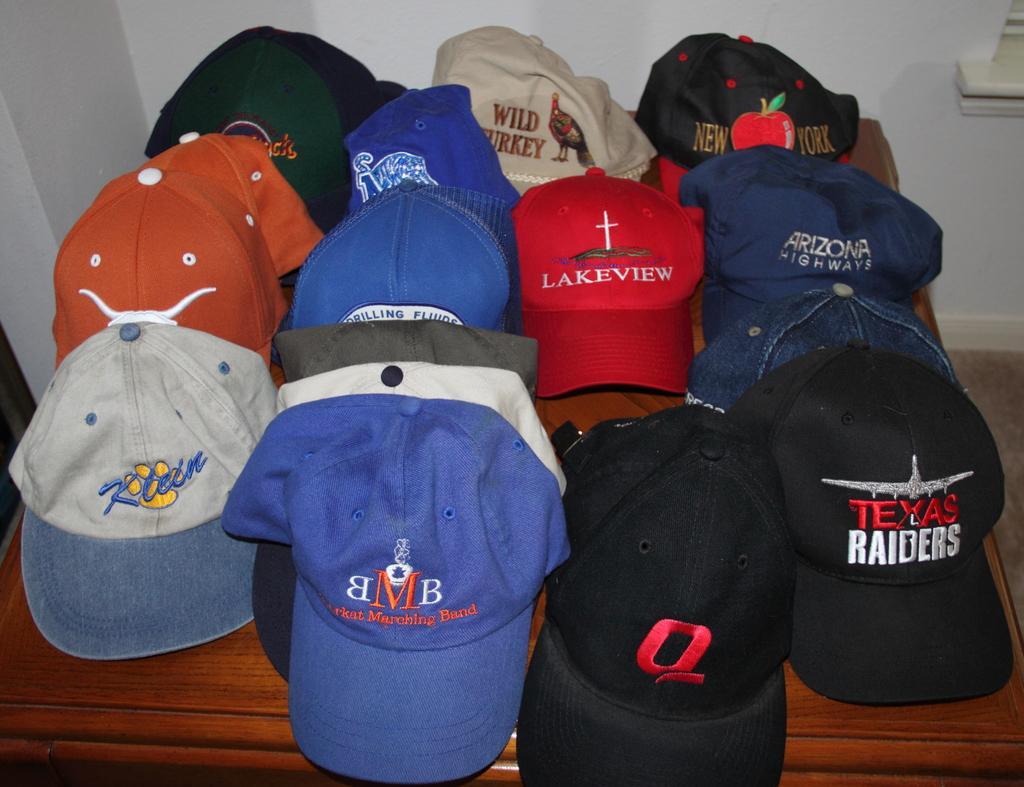How would you summarize this image in a sentence or two? As we can see in the image there is a white color wall and table. On table there are different colors of caps. 